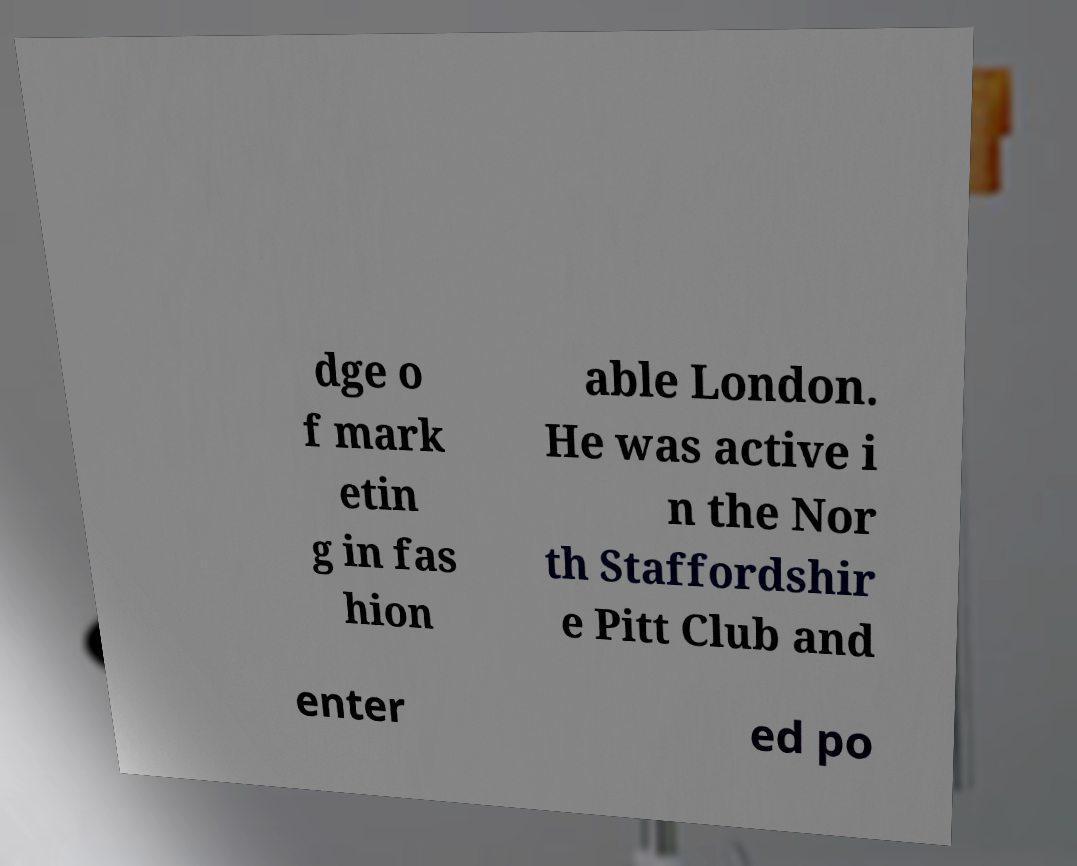Could you assist in decoding the text presented in this image and type it out clearly? dge o f mark etin g in fas hion able London. He was active i n the Nor th Staffordshir e Pitt Club and enter ed po 